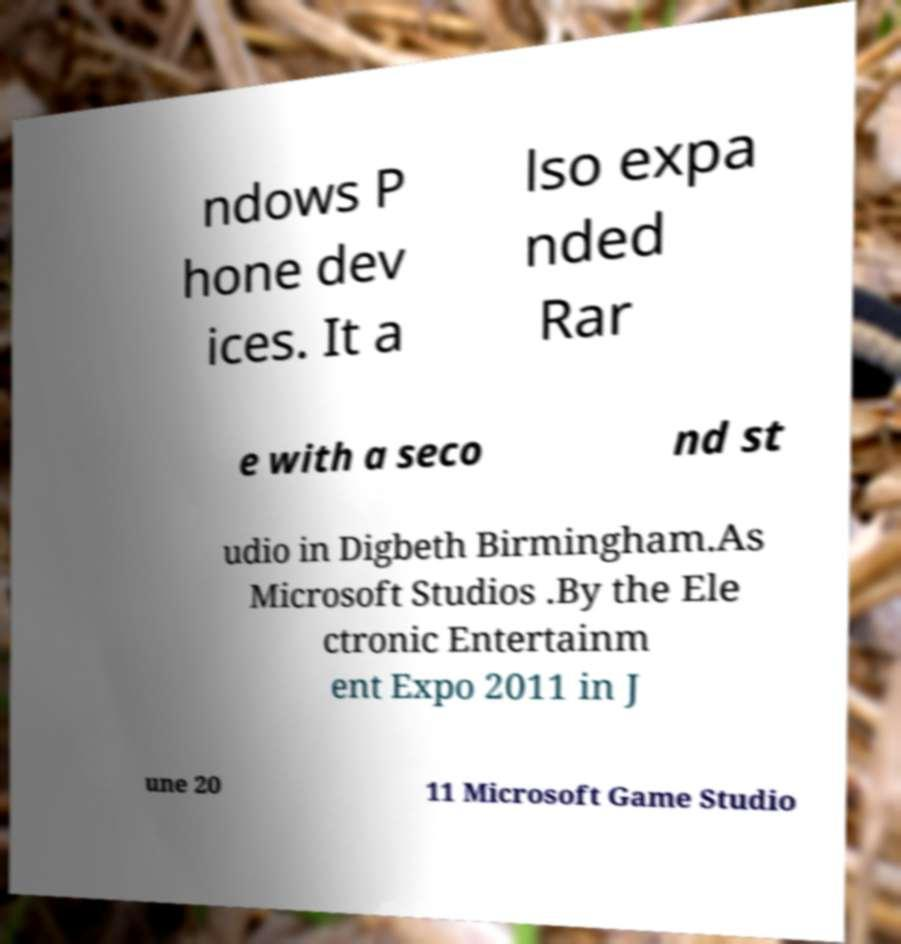There's text embedded in this image that I need extracted. Can you transcribe it verbatim? ndows P hone dev ices. It a lso expa nded Rar e with a seco nd st udio in Digbeth Birmingham.As Microsoft Studios .By the Ele ctronic Entertainm ent Expo 2011 in J une 20 11 Microsoft Game Studio 